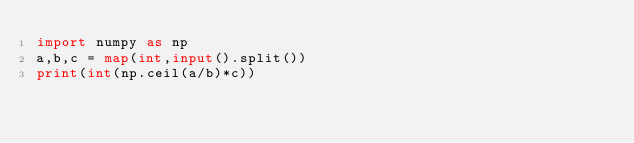<code> <loc_0><loc_0><loc_500><loc_500><_Python_>import numpy as np
a,b,c = map(int,input().split())
print(int(np.ceil(a/b)*c))</code> 